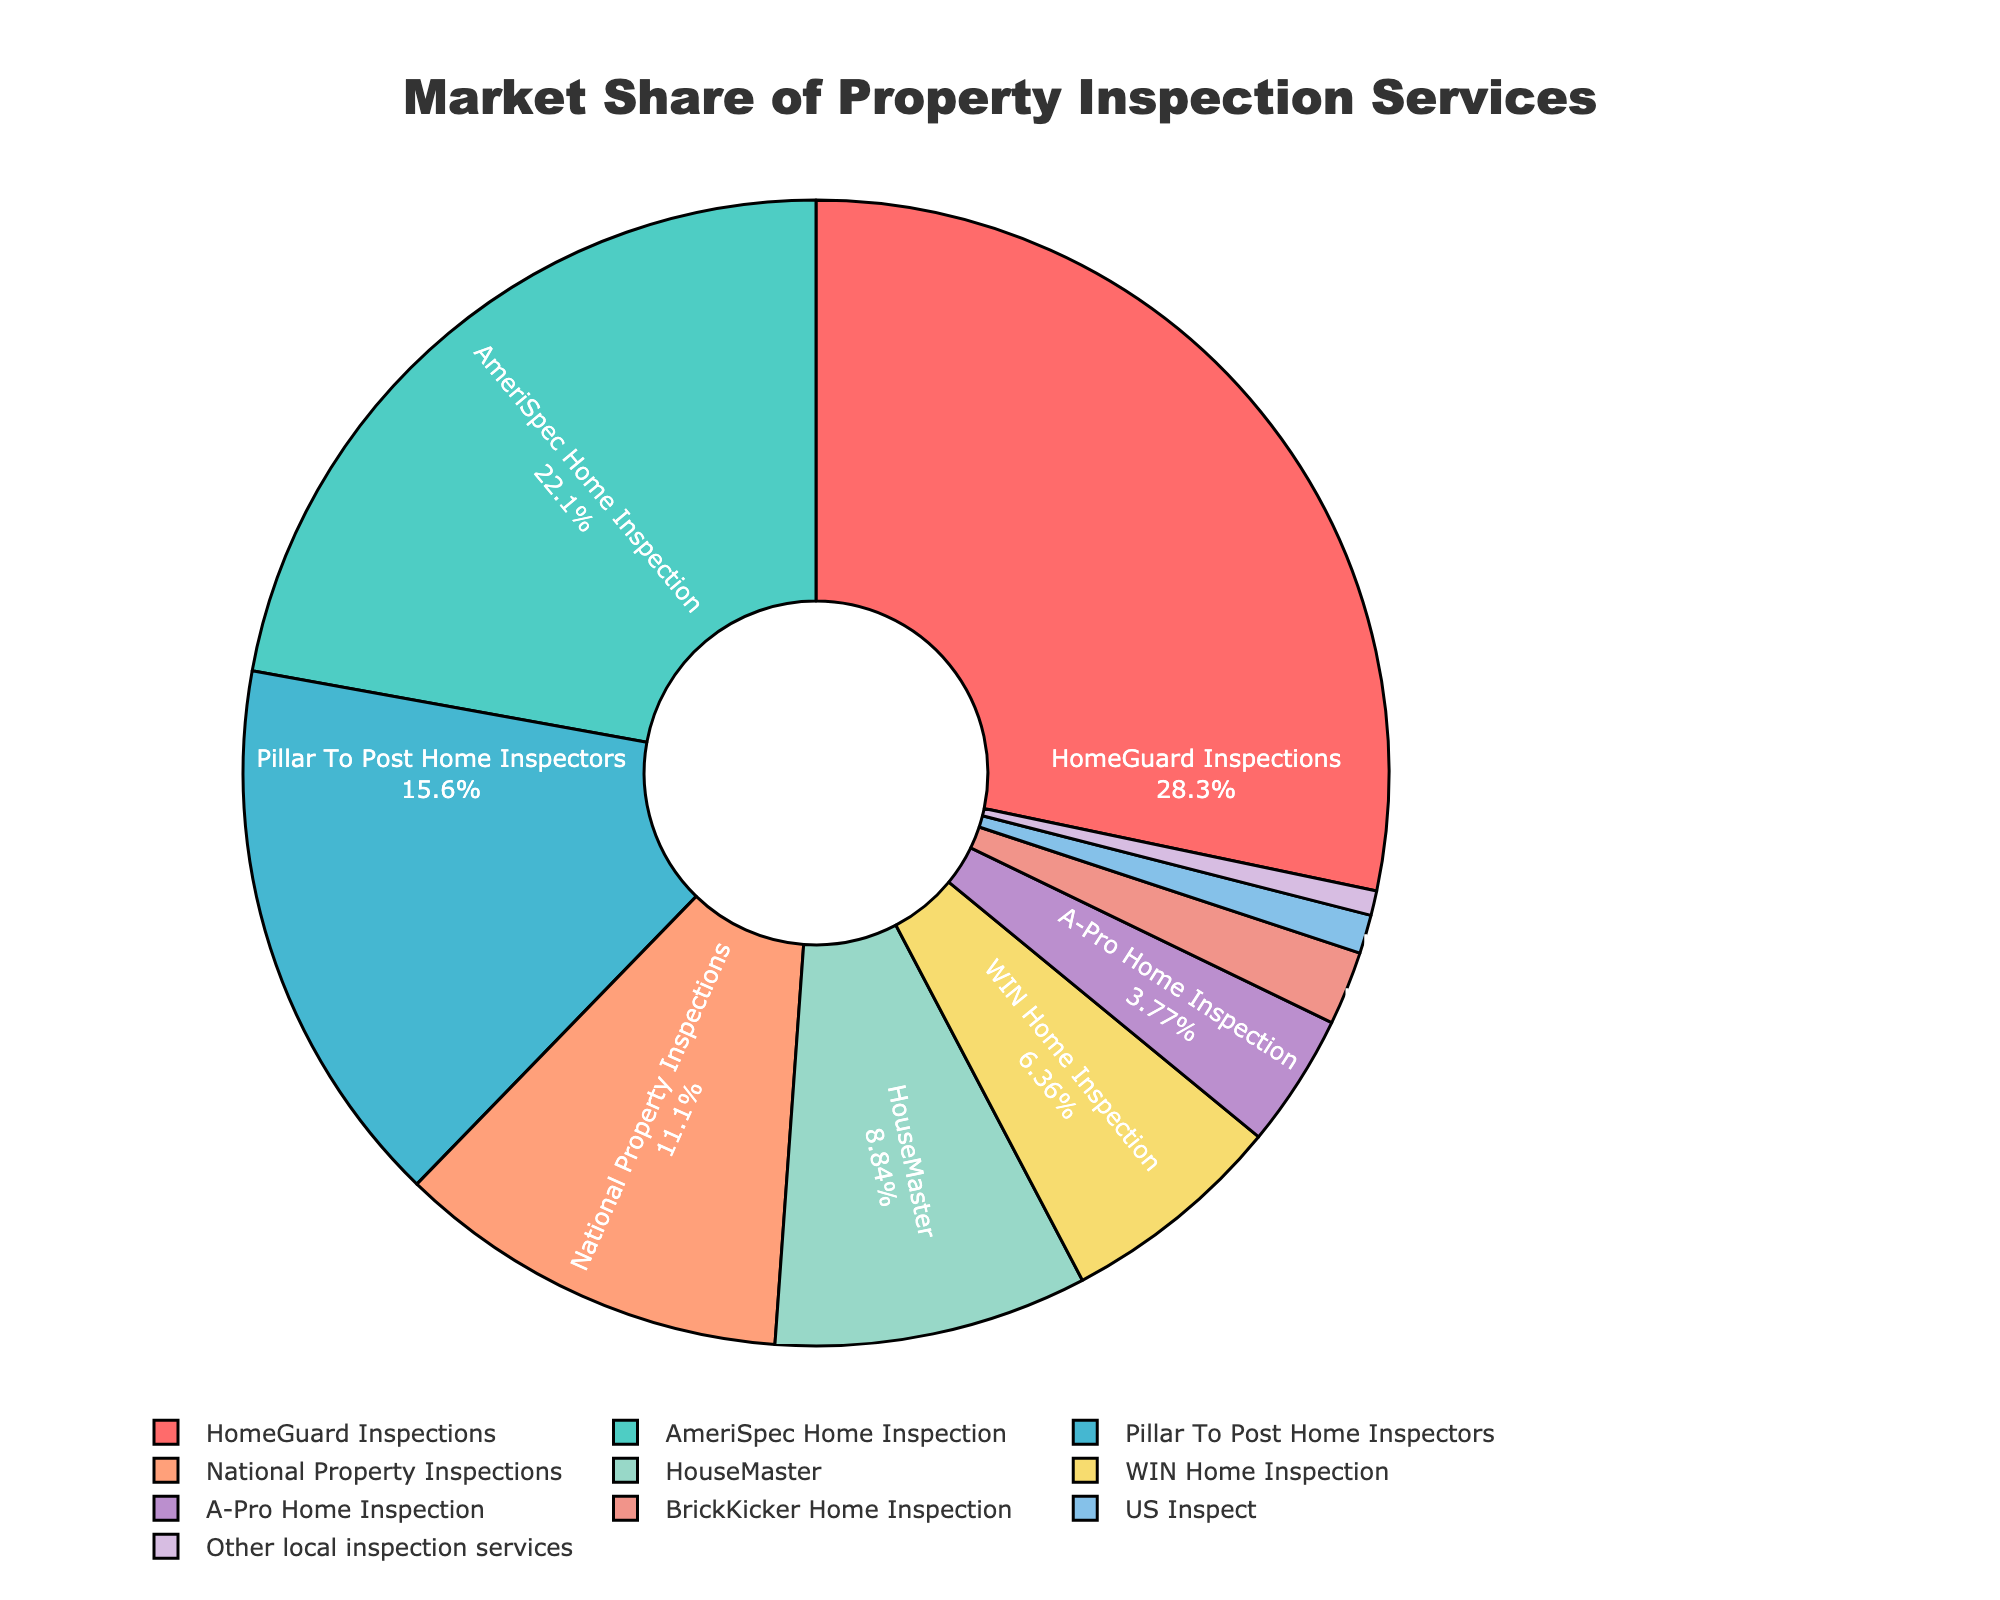Which service has the largest market share? HomeGuard Inspections has the largest market share at 28.5%. This can be directly observed from the pie chart where the section for HomeGuard Inspections is the largest.
Answer: HomeGuard Inspections What is the combined market share of HomeGuard Inspections and AmeriSpec Home Inspection? To find the combined market share, add the individual shares of HomeGuard Inspections and AmeriSpec Home Inspection. 28.5% + 22.3% = 50.8%.
Answer: 50.8% Which services have a market share less than 5%? The services with a market share less than 5% are A-Pro Home Inspection (3.8%), BrickKicker Home Inspection (2.1%), US Inspect (1.1%), and Other local inspection services (0.7%). This is visible from the smaller sections of the pie chart.
Answer: A-Pro Home Inspection, BrickKicker Home Inspection, US Inspect, Other local inspection services How does the market share of National Property Inspections compare to that of HouseMaster? National Property Inspections has a market share of 11.2%, while HouseMaster has a market share of 8.9%. Thus, National Property Inspections has a higher market share compared to HouseMaster.
Answer: National Property Inspections has a higher market share What is the difference in market share between Pillar To Post Home Inspectors and WIN Home Inspection? The market share of Pillar To Post Home Inspectors is 15.7%, and WIN Home Inspection is 6.4%. The difference is 15.7% - 6.4% = 9.3%.
Answer: 9.3% Which colors represent HomeGuard Inspections and AmeriSpec Home Inspection, respectively? HomeGuard Inspections is represented by red, while AmeriSpec Home Inspection is represented by green. This can be identified by looking at the color assigned to each label on the pie chart.
Answer: Red for HomeGuard Inspections, Green for AmeriSpec Home Inspection Which service has the smallest market share, and what is its percentage? Other local inspection services has the smallest market share at 0.7%. This can be seen from the smallest section in the pie chart.
Answer: Other local inspection services, 0.7% Is the combined market share of other local inspection services and US Inspect greater than that of WIN Home Inspection? The combined market share of other local inspection services (0.7%) and US Inspect (1.1%) is 0.7% + 1.1% = 1.8%. This is less than the market share of WIN Home Inspection (6.4%).
Answer: No, it is less 